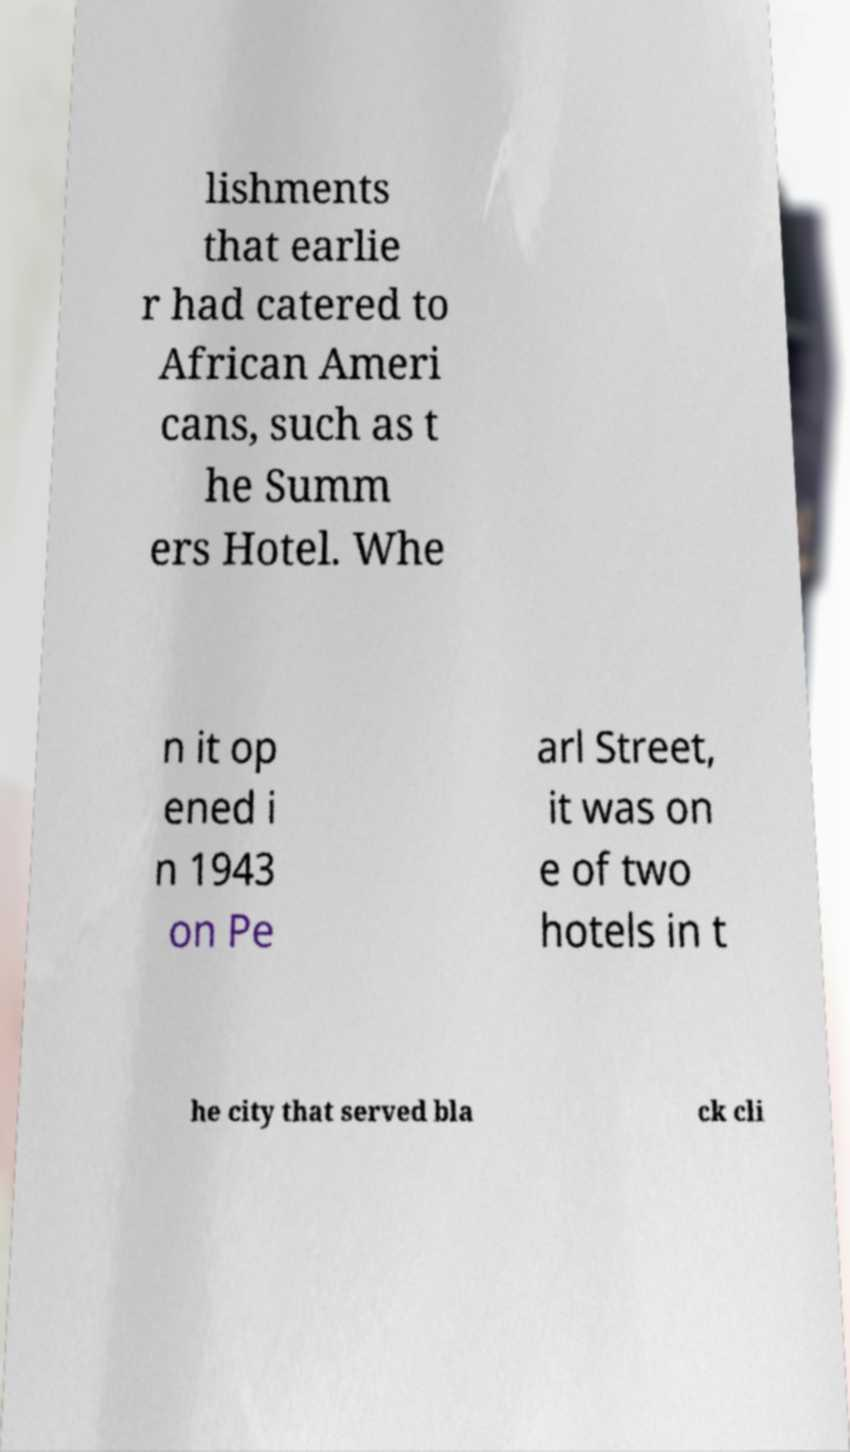I need the written content from this picture converted into text. Can you do that? lishments that earlie r had catered to African Ameri cans, such as t he Summ ers Hotel. Whe n it op ened i n 1943 on Pe arl Street, it was on e of two hotels in t he city that served bla ck cli 